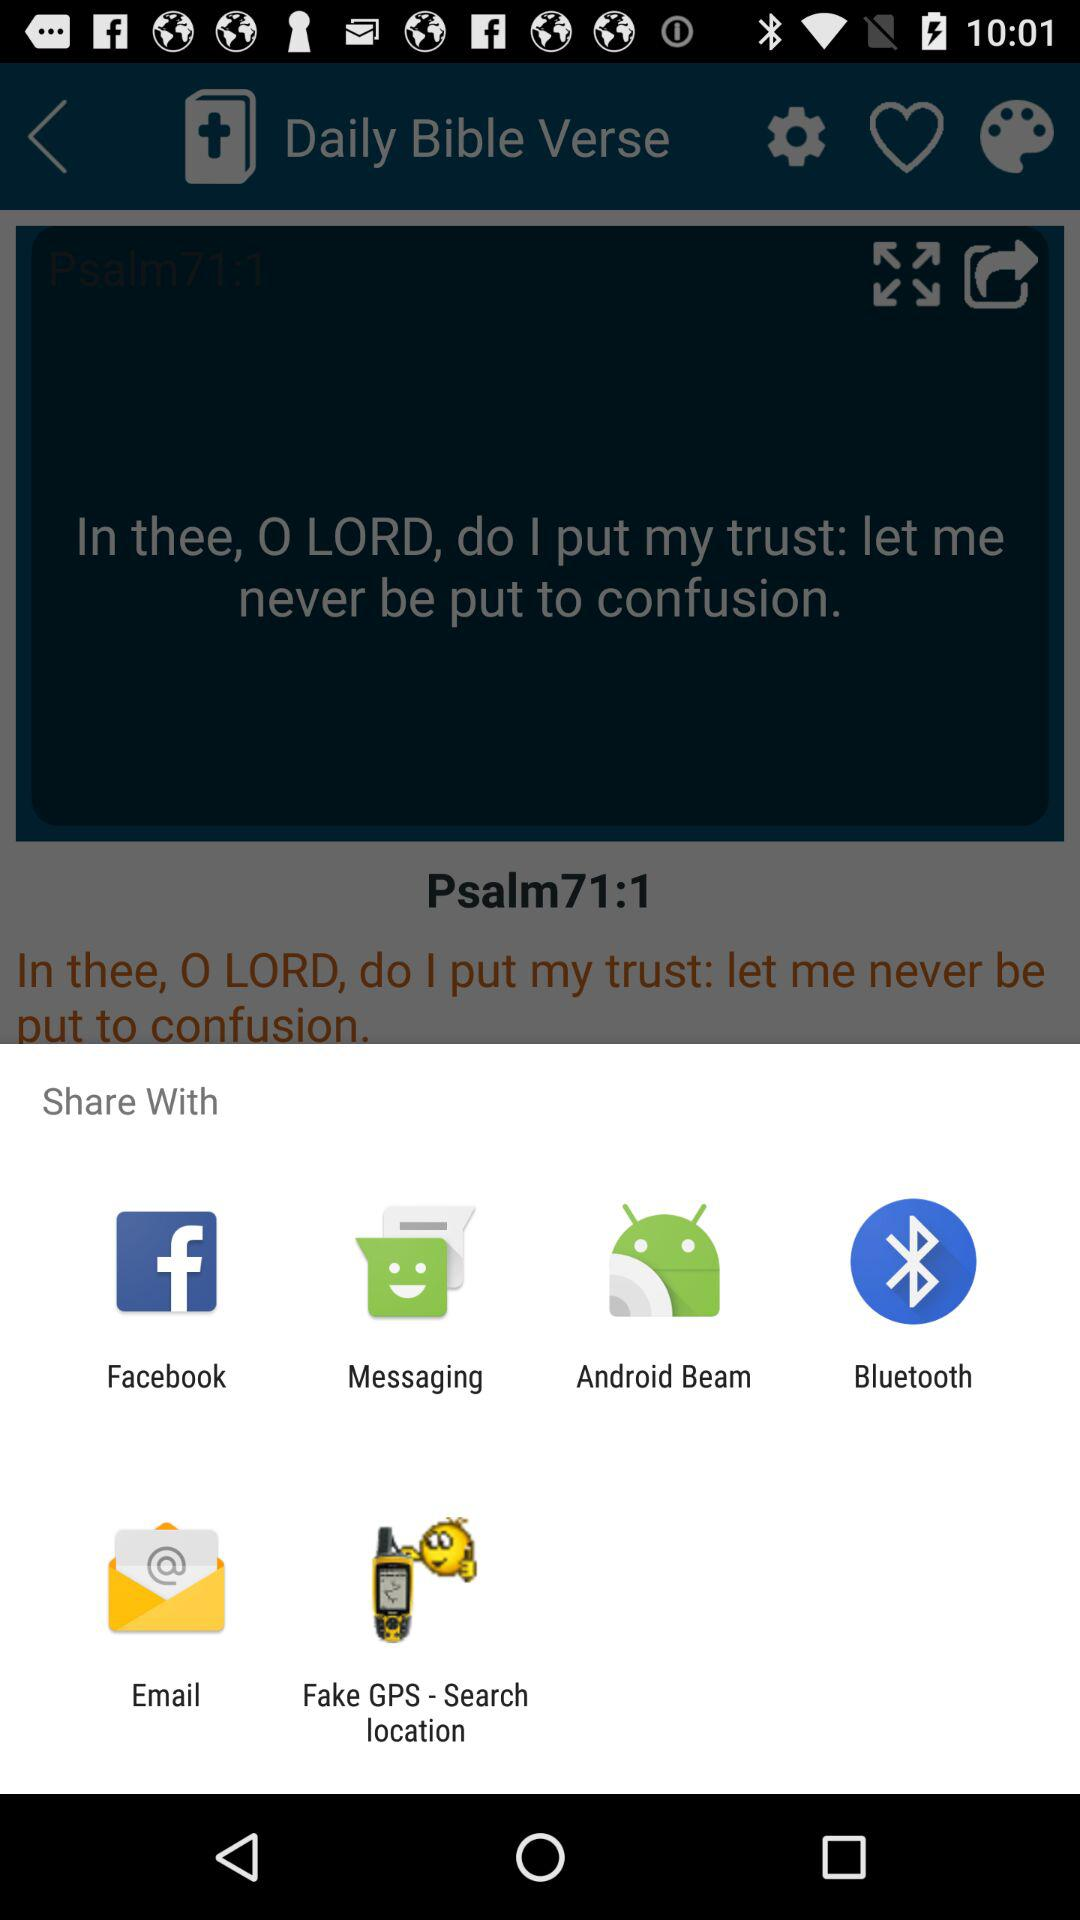With which app can we share it? You can share it with "Facebook", "Messaging", "Android Beam", "Bluetooth", "Email" and "Fake GPS - Search location". 